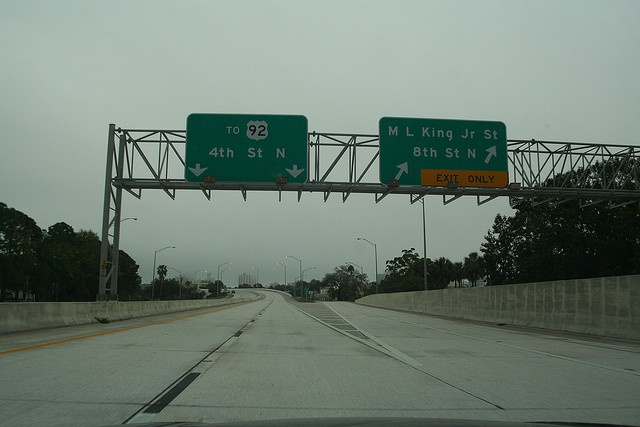Describe the objects in this image and their specific colors. I can see various objects in this image with different colors. 